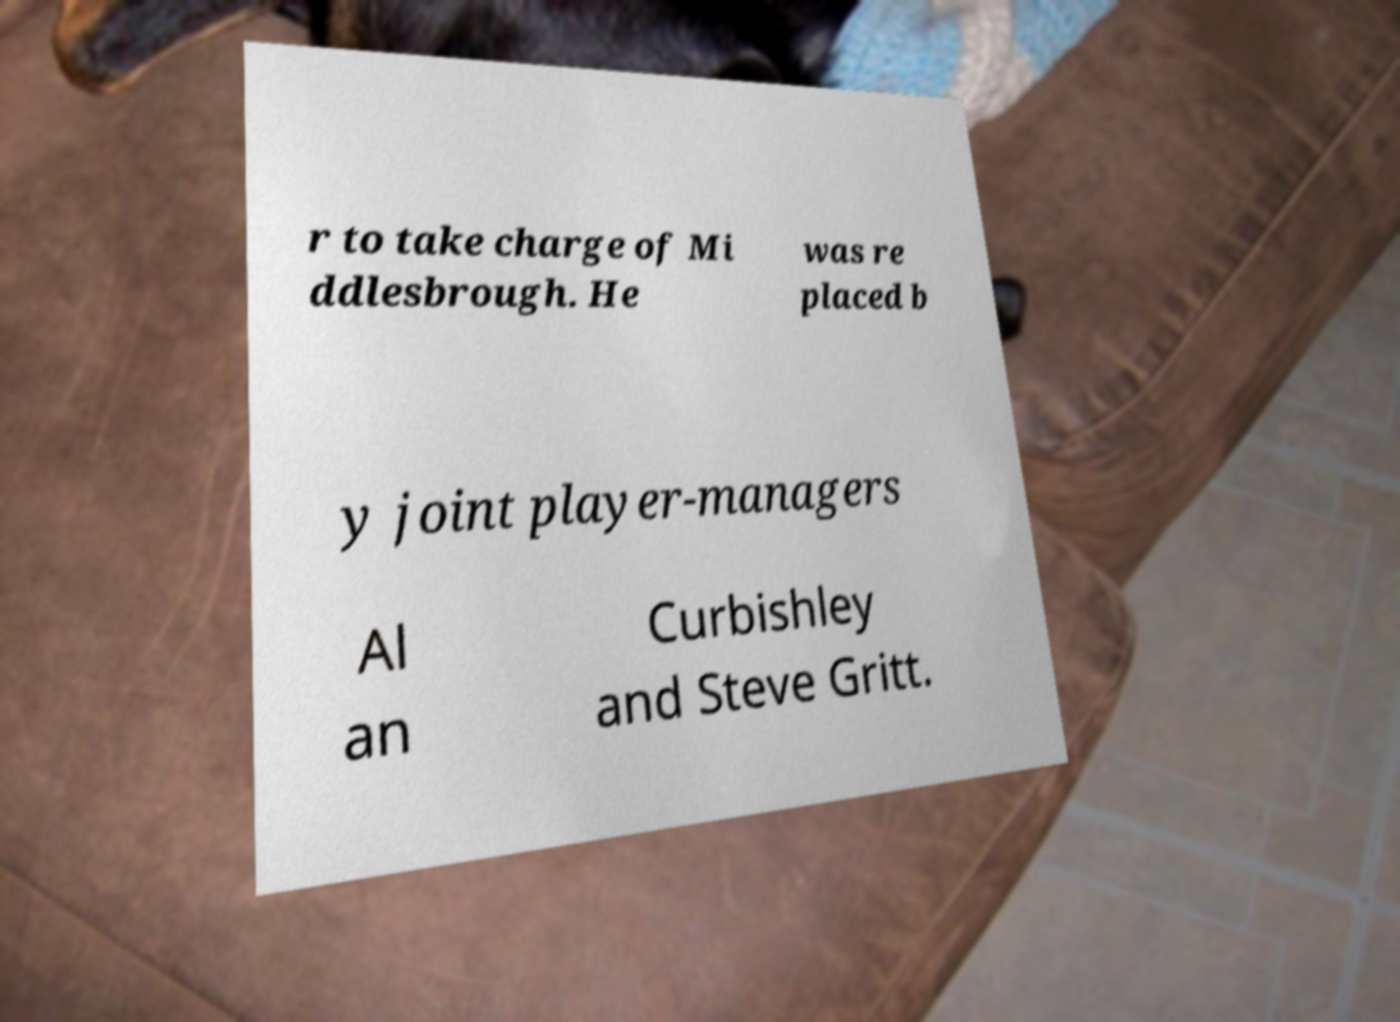Please identify and transcribe the text found in this image. r to take charge of Mi ddlesbrough. He was re placed b y joint player-managers Al an Curbishley and Steve Gritt. 